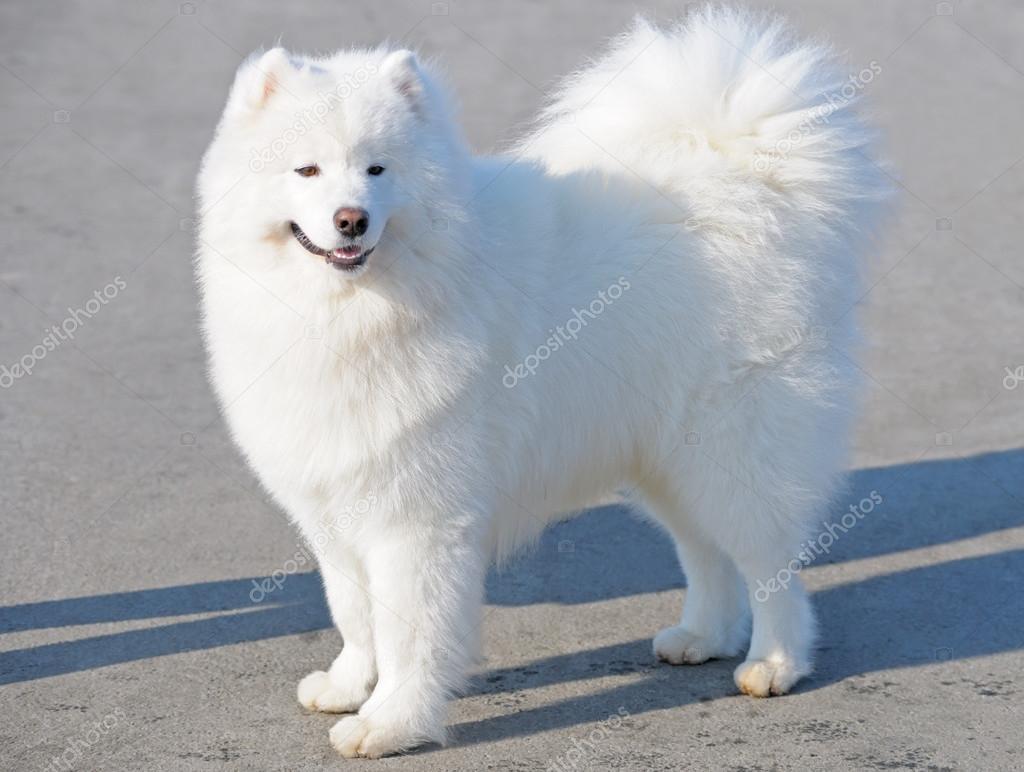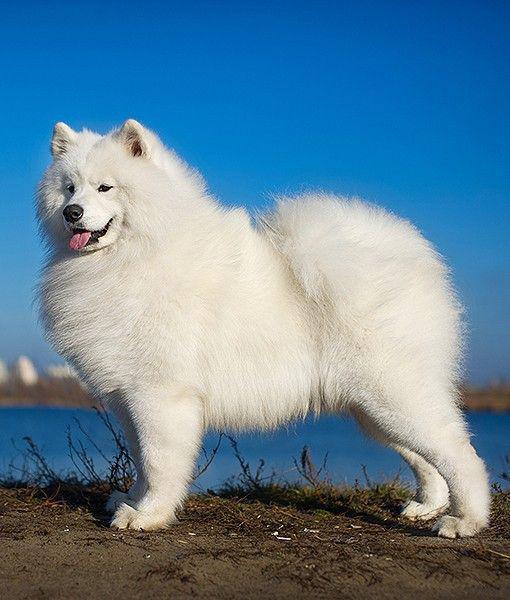The first image is the image on the left, the second image is the image on the right. For the images displayed, is the sentence "At least one dog is standing on asphalt." factually correct? Answer yes or no. Yes. 